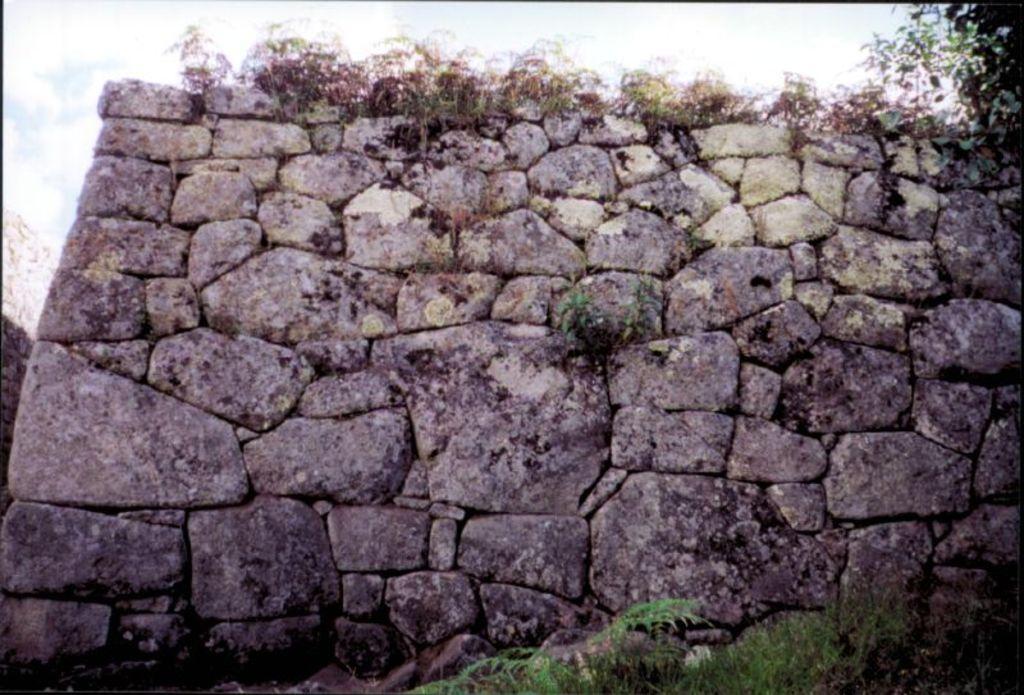Could you give a brief overview of what you see in this image? This is a wall, which is built with the rocks. I can see the plants. This looks like a tree. 